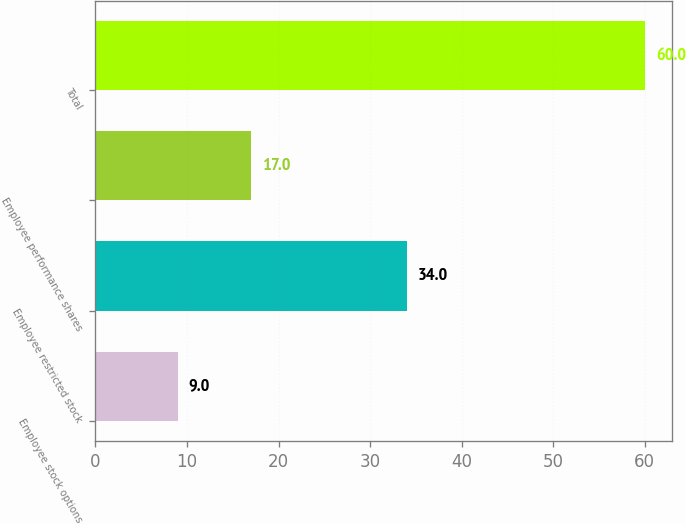<chart> <loc_0><loc_0><loc_500><loc_500><bar_chart><fcel>Employee stock options<fcel>Employee restricted stock<fcel>Employee performance shares<fcel>Total<nl><fcel>9<fcel>34<fcel>17<fcel>60<nl></chart> 